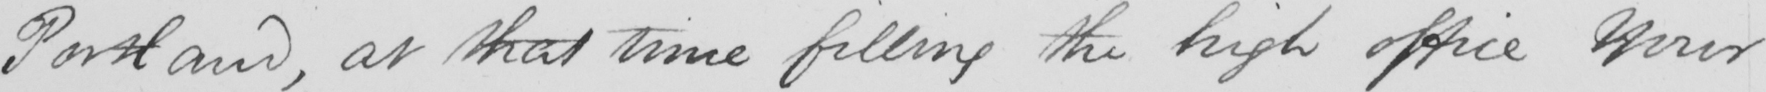Please transcribe the handwritten text in this image. Portland , at that time filling the high office Your 